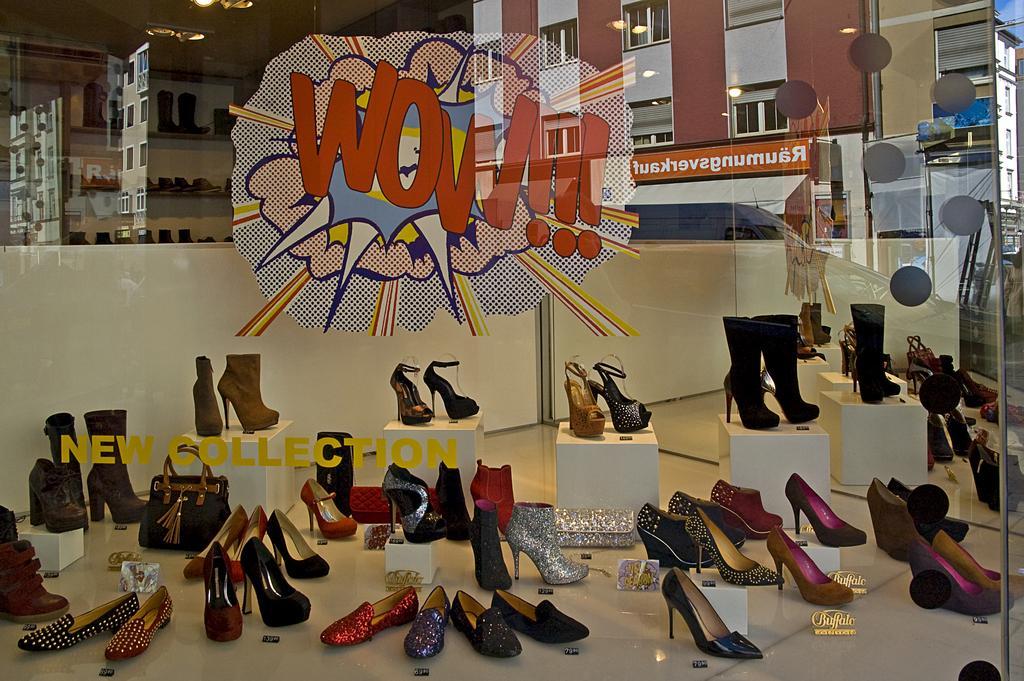Please provide a concise description of this image. In front of the image there is a glass wall with logo and text on it, through the glass wall we can see there is footwear on the display. On the glass we can see the reflection of buildings with name boards on it. 